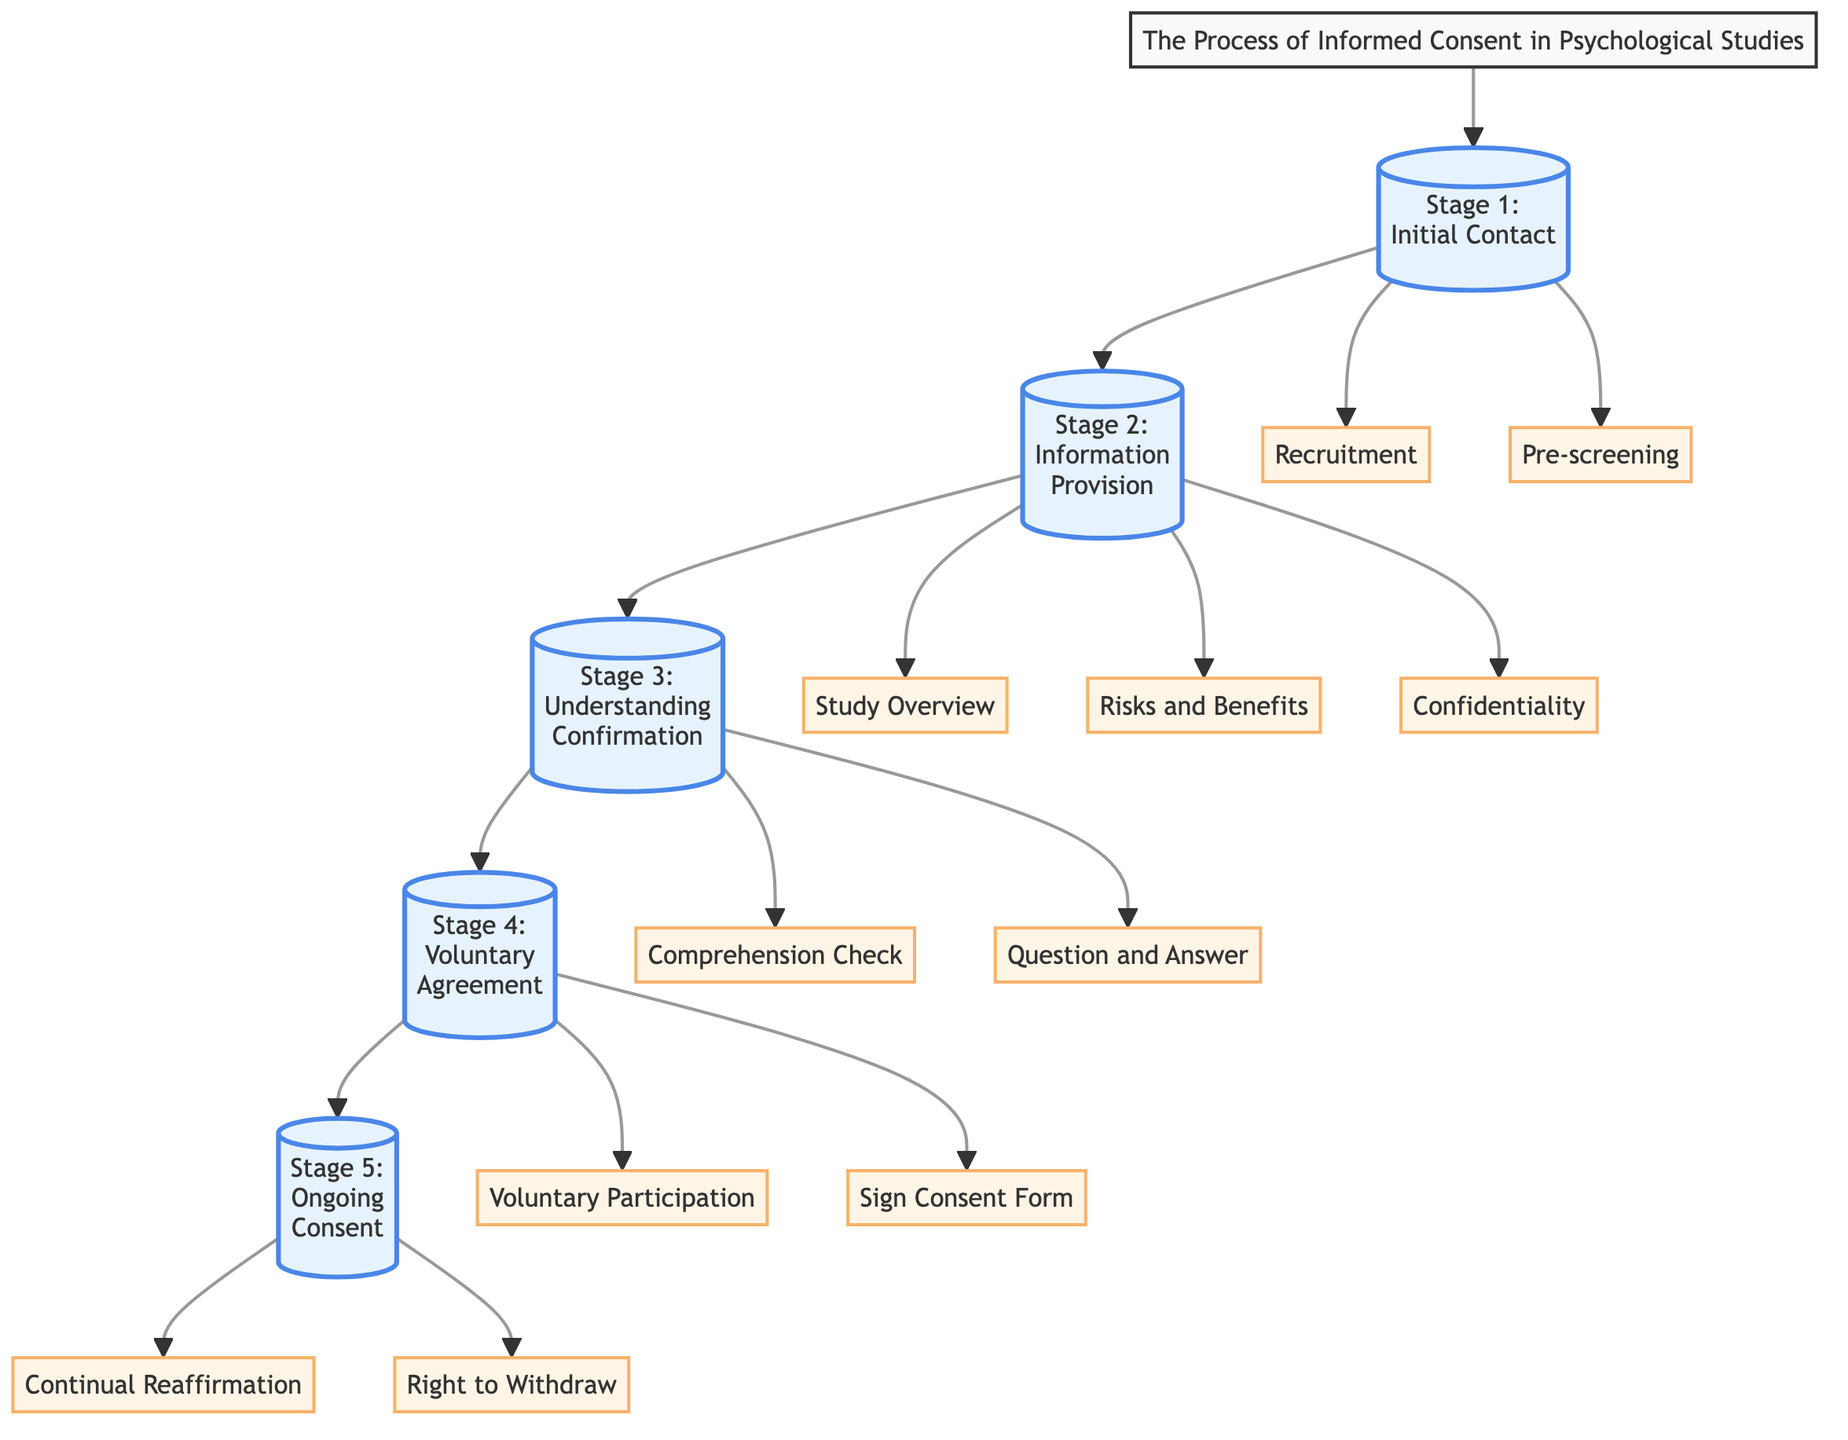What is the first stage in the process? The process starts with "Initial Contact," which is identified as the first node in the flowchart. This node is connected directly after the title, indicating it is the beginning of the informed consent process.
Answer: Initial Contact How many stages are present in the process? By counting the different stages represented in the flowchart, we identify five distinct stages: Initial Contact, Information Provision, Understanding Confirmation, Voluntary Agreement, and Ongoing Consent.
Answer: 5 What is the content of Stage 2? The second stage is labeled as "Information Provision," which reflects the title text displayed within the corresponding node. The content is a crucial part of the informed consent process.
Answer: Information Provision Which element indicates participants' rights to withdraw? The element labeled "Right to Withdraw" is specified in Stage 5, as it is a key part of ongoing consent for the participants in psychological studies.
Answer: Right to Withdraw What follows after "Understanding Confirmation"? The flowchart shows that "Voluntary Agreement" directly follows "Understanding Confirmation" in the sequence of the informed consent process, indicating a logical progression to obtaining consent.
Answer: Voluntary Agreement What are the two components of the first stage? The first stage consists of two components: "Recruitment" and "Pre-screening," indicating initial steps taken to engage potential study participants.
Answer: Recruitment and Pre-screening How many components are there in the "Information Provision" stage? In the "Information Provision" stage, there are three components: "Study Overview," "Risks and Benefits," and "Confidentiality," as indicated within the connected elements under this stage.
Answer: 3 What is necessary to confirm understanding before moving to voluntary agreement? A "Comprehension Check" is necessary, along with a "Question and Answer" session, to ensure that participants understand the information provided before they can give their voluntary agreement.
Answer: Comprehension Check and Question and Answer What is the last aspect of the informed consent process? The last aspect of the process is indicated as "Continual Reaffirmation," which emphasizes the ongoing nature of consent as studies progress.
Answer: Continual Reaffirmation 